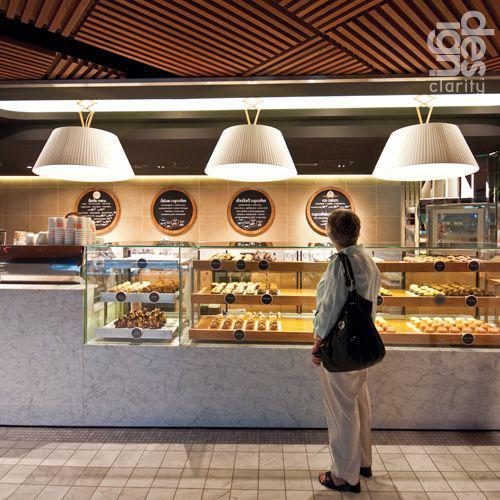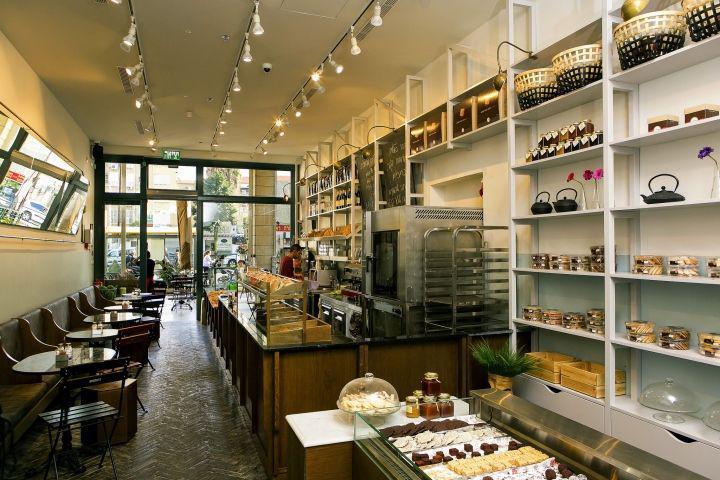The first image is the image on the left, the second image is the image on the right. Assess this claim about the two images: "The bakery in one image has white tile walls and uses black paddles for signs.". Correct or not? Answer yes or no. No. 